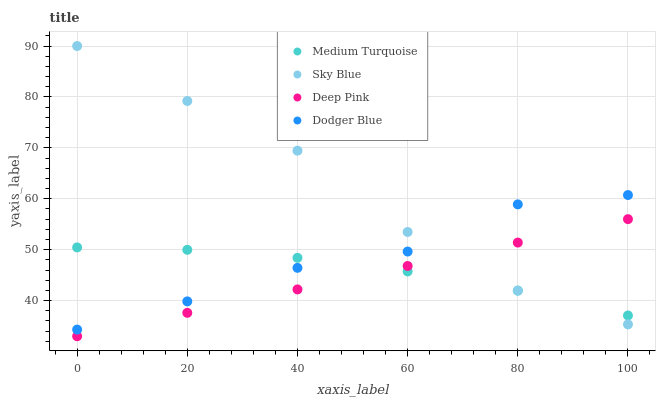Does Deep Pink have the minimum area under the curve?
Answer yes or no. Yes. Does Sky Blue have the maximum area under the curve?
Answer yes or no. Yes. Does Dodger Blue have the minimum area under the curve?
Answer yes or no. No. Does Dodger Blue have the maximum area under the curve?
Answer yes or no. No. Is Deep Pink the smoothest?
Answer yes or no. Yes. Is Dodger Blue the roughest?
Answer yes or no. Yes. Is Dodger Blue the smoothest?
Answer yes or no. No. Is Deep Pink the roughest?
Answer yes or no. No. Does Deep Pink have the lowest value?
Answer yes or no. Yes. Does Dodger Blue have the lowest value?
Answer yes or no. No. Does Sky Blue have the highest value?
Answer yes or no. Yes. Does Deep Pink have the highest value?
Answer yes or no. No. Is Deep Pink less than Dodger Blue?
Answer yes or no. Yes. Is Dodger Blue greater than Deep Pink?
Answer yes or no. Yes. Does Sky Blue intersect Medium Turquoise?
Answer yes or no. Yes. Is Sky Blue less than Medium Turquoise?
Answer yes or no. No. Is Sky Blue greater than Medium Turquoise?
Answer yes or no. No. Does Deep Pink intersect Dodger Blue?
Answer yes or no. No. 